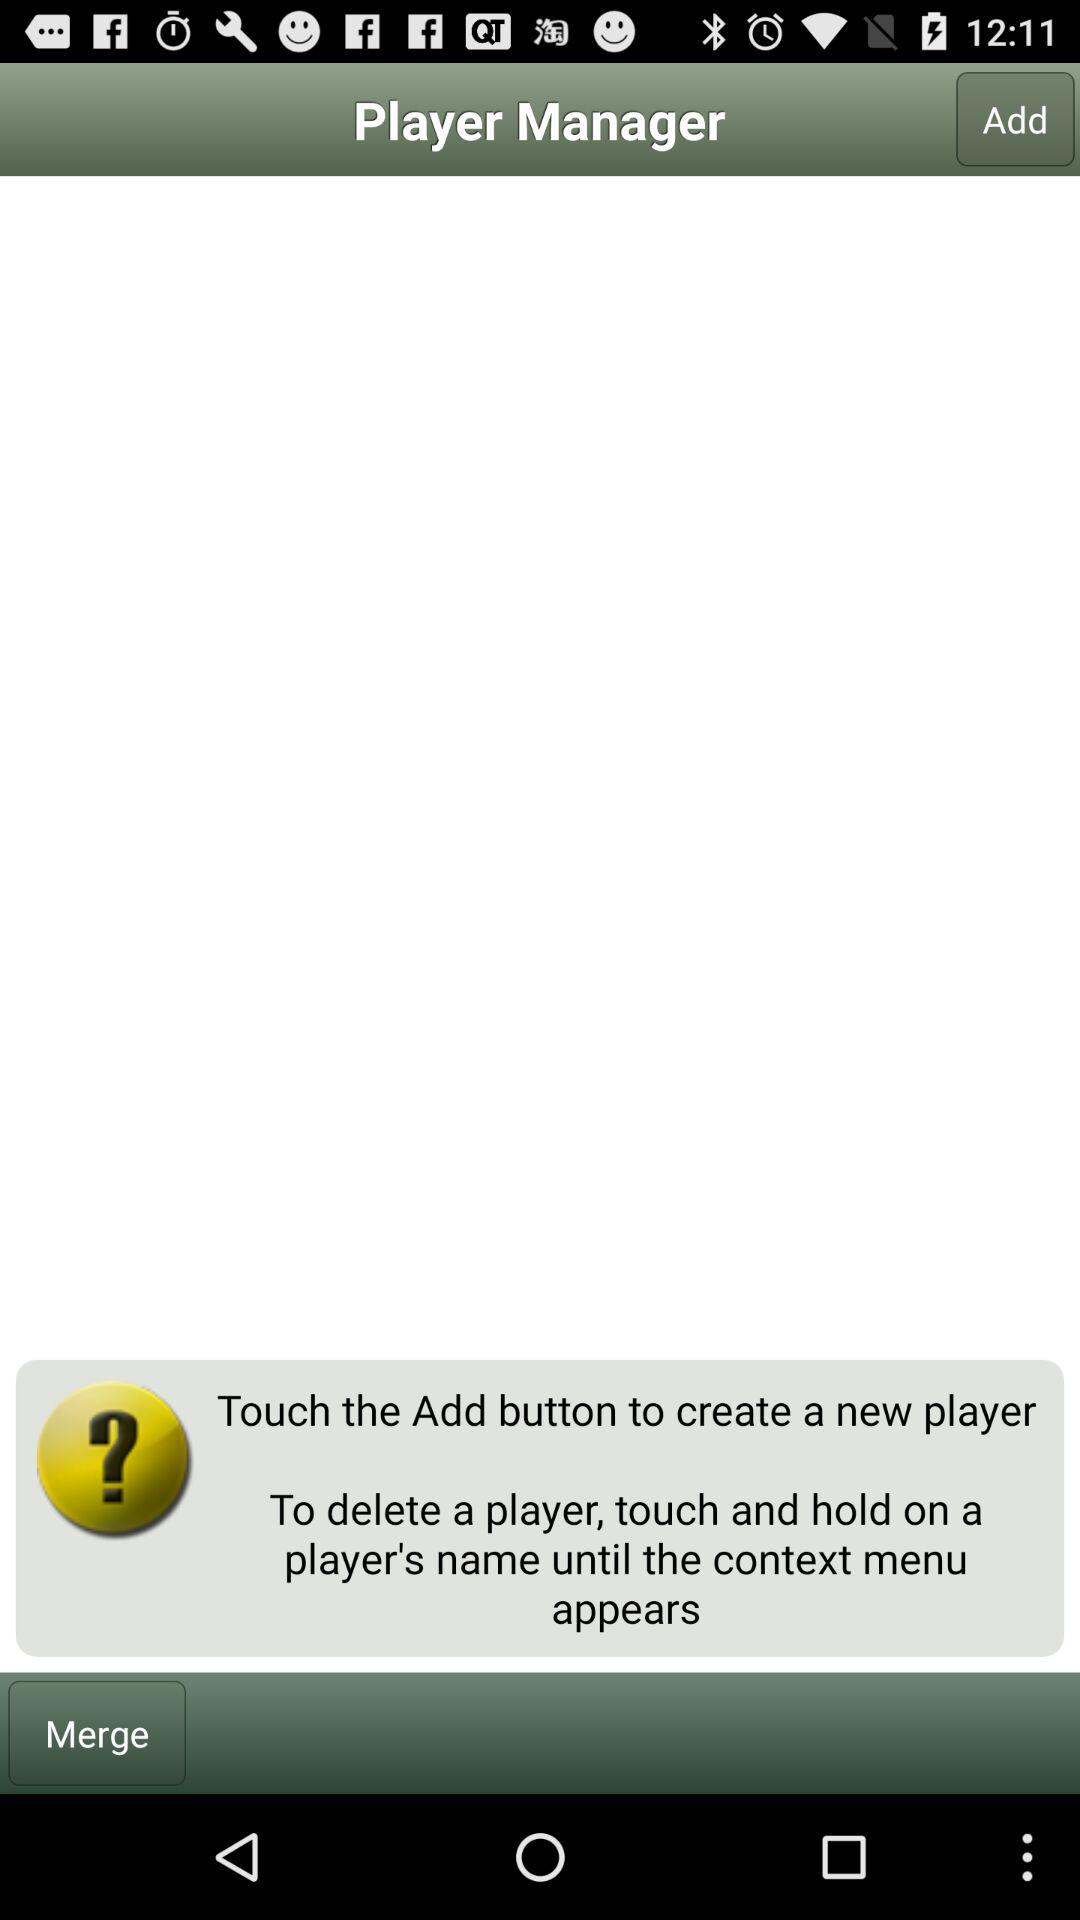What is the name of application? The name of the application is "Player Manager". 